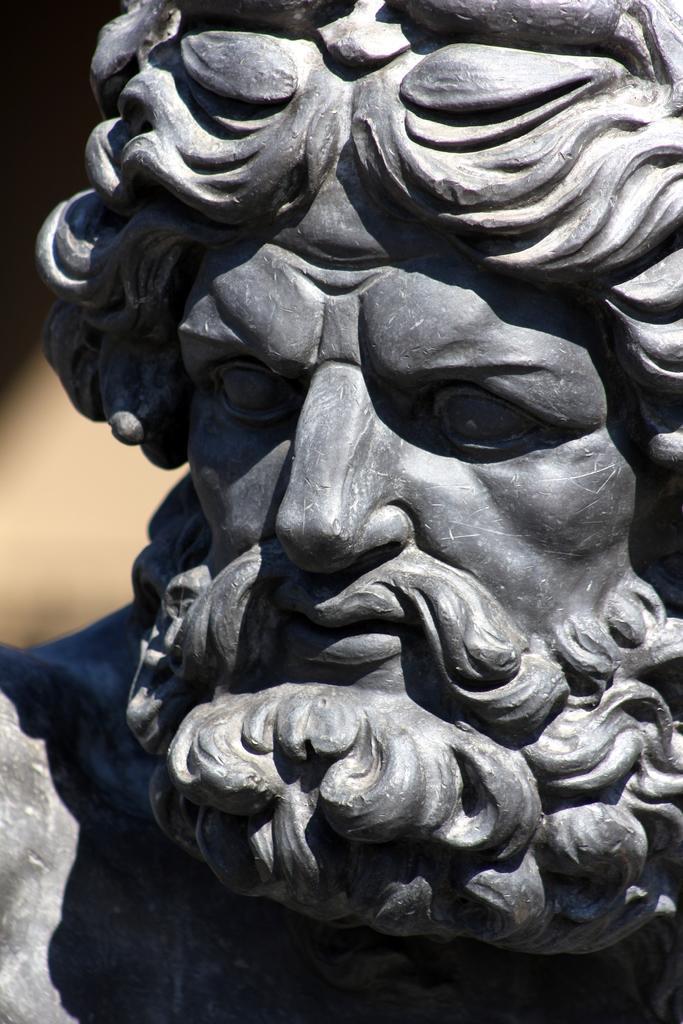Please provide a concise description of this image. In this picture we can see a statue of a man and in the background it is dark. 